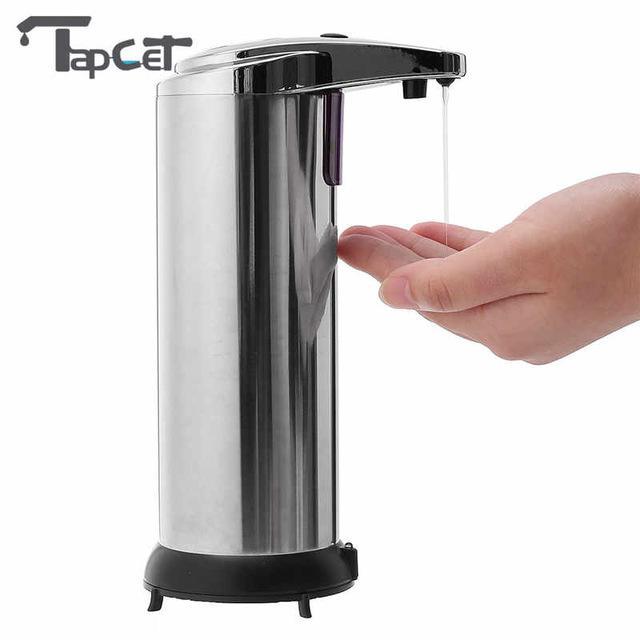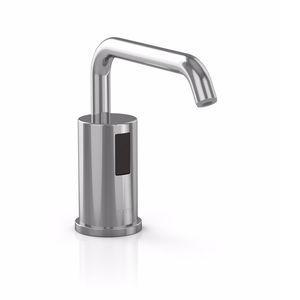The first image is the image on the left, the second image is the image on the right. Assess this claim about the two images: "There is one dispenser attached to a plastic bottle.". Correct or not? Answer yes or no. No. The first image is the image on the left, the second image is the image on the right. Considering the images on both sides, is "The left and right image contains the same number of sink soap dispensers." valid? Answer yes or no. Yes. 